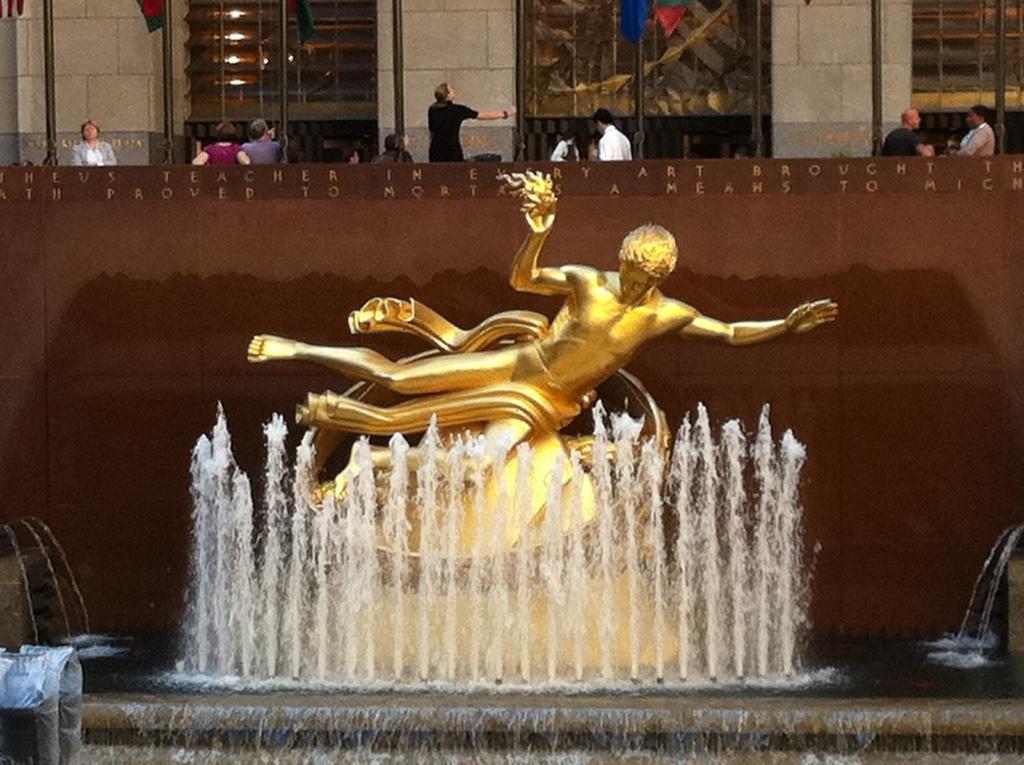Could you give a brief overview of what you see in this image? In this image, we can see a statue. We can also see the waterfall. We can see the wall with some text. There are a few people. We can see some flags, poles. We can also see some glass. 